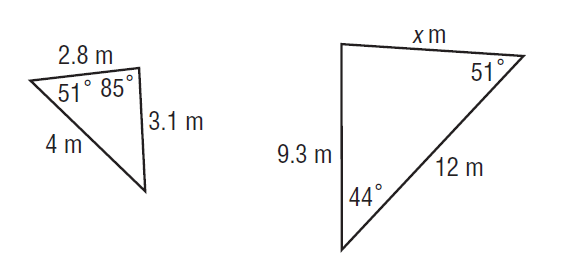Question: Find x.
Choices:
A. 4.2
B. 4.65
C. 5.6
D. 8.4
Answer with the letter. Answer: D 